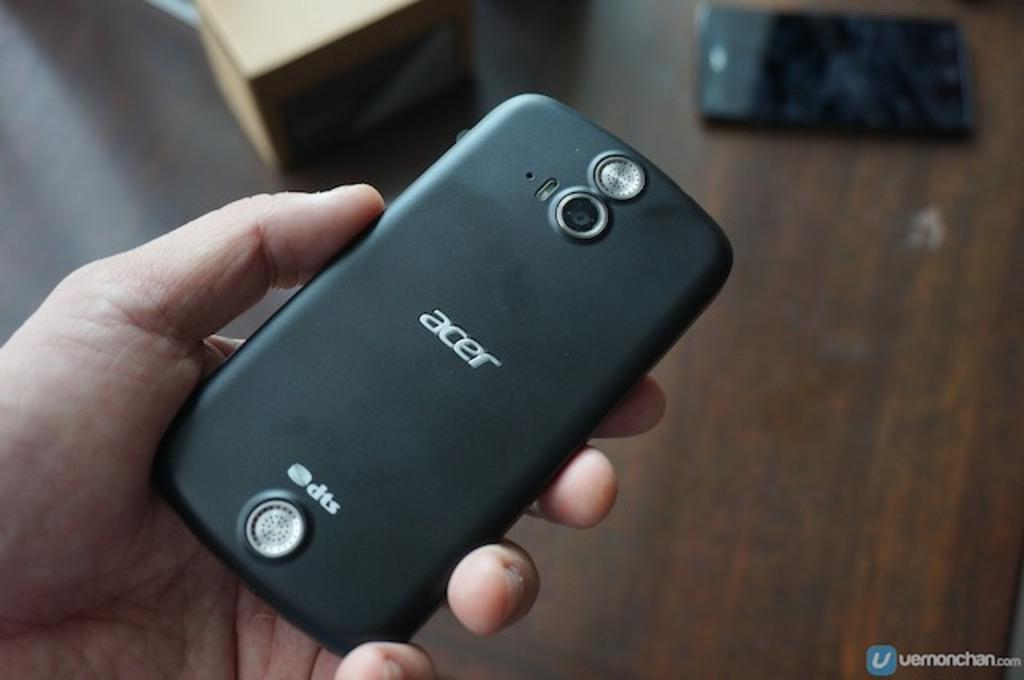<image>
Share a concise interpretation of the image provided. the back of an ACER phone held in a hand 